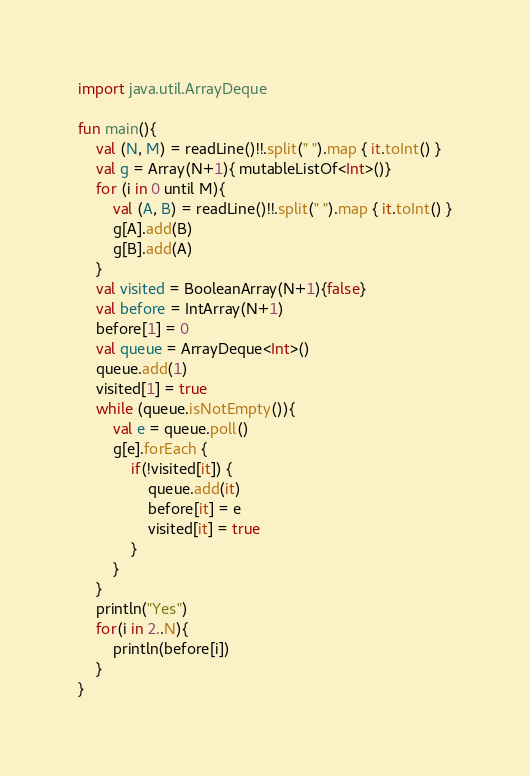<code> <loc_0><loc_0><loc_500><loc_500><_Kotlin_>import java.util.ArrayDeque

fun main(){
    val (N, M) = readLine()!!.split(" ").map { it.toInt() }
    val g = Array(N+1){ mutableListOf<Int>()}
    for (i in 0 until M){
        val (A, B) = readLine()!!.split(" ").map { it.toInt() }
        g[A].add(B)
        g[B].add(A)
    }
    val visited = BooleanArray(N+1){false}
    val before = IntArray(N+1)
    before[1] = 0
    val queue = ArrayDeque<Int>()
    queue.add(1)
    visited[1] = true
    while (queue.isNotEmpty()){
        val e = queue.poll()
        g[e].forEach {
            if(!visited[it]) {
                queue.add(it)
                before[it] = e
                visited[it] = true
            }
        }
    }
    println("Yes")
    for(i in 2..N){
        println(before[i])
    }
}</code> 